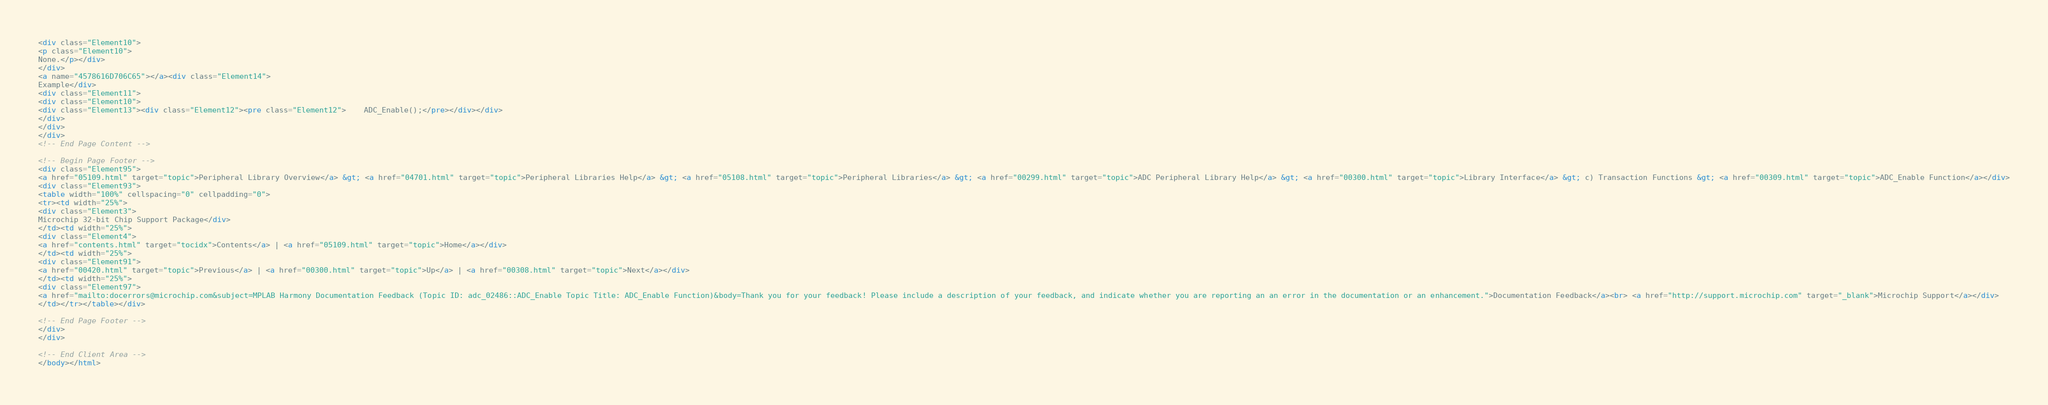Convert code to text. <code><loc_0><loc_0><loc_500><loc_500><_HTML_><div class="Element10">
<p class="Element10">
None.</p></div>
</div>
<a name="4578616D706C65"></a><div class="Element14">
Example</div>
<div class="Element11">
<div class="Element10">
<div class="Element13"><div class="Element12"><pre class="Element12">    ADC_Enable();</pre></div></div>
</div>
</div>
</div>
<!-- End Page Content -->

<!-- Begin Page Footer -->
<div class="Element95">
<a href="05109.html" target="topic">Peripheral Library Overview</a> &gt; <a href="04701.html" target="topic">Peripheral Libraries Help</a> &gt; <a href="05108.html" target="topic">Peripheral Libraries</a> &gt; <a href="00299.html" target="topic">ADC Peripheral Library Help</a> &gt; <a href="00300.html" target="topic">Library Interface</a> &gt; c) Transaction Functions &gt; <a href="00309.html" target="topic">ADC_Enable Function</a></div>
<div class="Element93">
<table width="100%" cellspacing="0" cellpadding="0">
<tr><td width="25%">
<div class="Element3">
Microchip 32-bit Chip Support Package</div>
</td><td width="25%">
<div class="Element4">
<a href="contents.html" target="tocidx">Contents</a> | <a href="05109.html" target="topic">Home</a></div>
</td><td width="25%">
<div class="Element91">
<a href="00420.html" target="topic">Previous</a> | <a href="00300.html" target="topic">Up</a> | <a href="00308.html" target="topic">Next</a></div>
</td><td width="25%">
<div class="Element97">
<a href="mailto:docerrors@microchip.com&subject=MPLAB Harmony Documentation Feedback (Topic ID: adc_02486::ADC_Enable Topic Title: ADC_Enable Function)&body=Thank you for your feedback! Please include a description of your feedback, and indicate whether you are reporting an an error in the documentation or an enhancement.">Documentation Feedback</a><br> <a href="http://support.microchip.com" target="_blank">Microchip Support</a></div>
</td></tr></table></div>

<!-- End Page Footer -->
</div>
</div>

<!-- End Client Area -->
</body></html></code> 